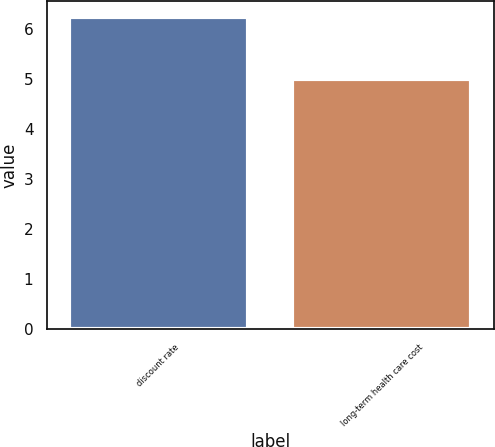Convert chart. <chart><loc_0><loc_0><loc_500><loc_500><bar_chart><fcel>discount rate<fcel>long-term health care cost<nl><fcel>6.25<fcel>5<nl></chart> 